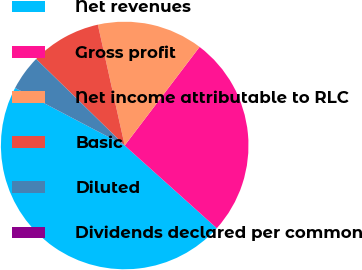Convert chart. <chart><loc_0><loc_0><loc_500><loc_500><pie_chart><fcel>Net revenues<fcel>Gross profit<fcel>Net income attributable to RLC<fcel>Basic<fcel>Diluted<fcel>Dividends declared per common<nl><fcel>46.05%<fcel>26.31%<fcel>13.82%<fcel>9.21%<fcel>4.61%<fcel>0.01%<nl></chart> 